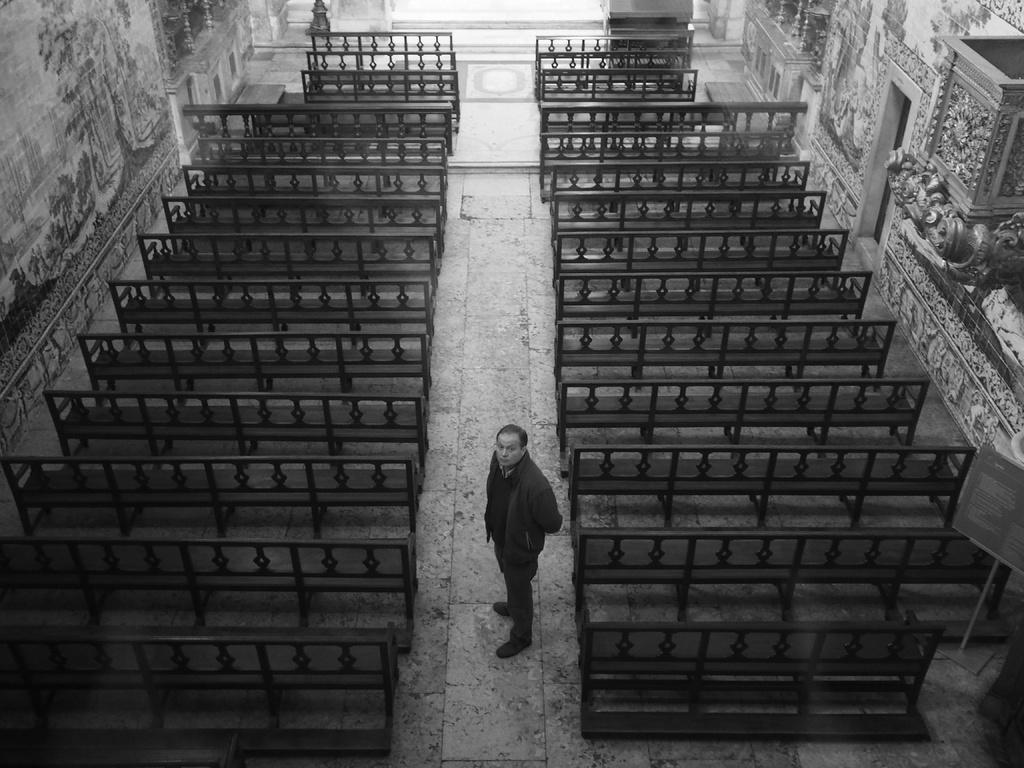What is the main subject of the image? There is a person standing in the image. What can be seen on the left side of the image? There are benches on the left side of the image. What can be seen on the right side of the image? There are benches on the right side of the image. How is the image presented in terms of color? The image is in black and white color. What type of representative is sitting on the benches in the image? There are no representatives present in the image; it only shows a person standing and benches on both sides. How does the person's stomach look in the image? The image is in black and white color, and there is no specific focus on the person's stomach, so it cannot be determined from the image. 